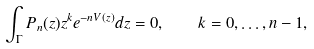<formula> <loc_0><loc_0><loc_500><loc_500>\int _ { \Gamma } P _ { n } ( z ) z ^ { k } e ^ { - n V ( z ) } d z = 0 , \quad k = 0 , \dots , n - 1 ,</formula> 